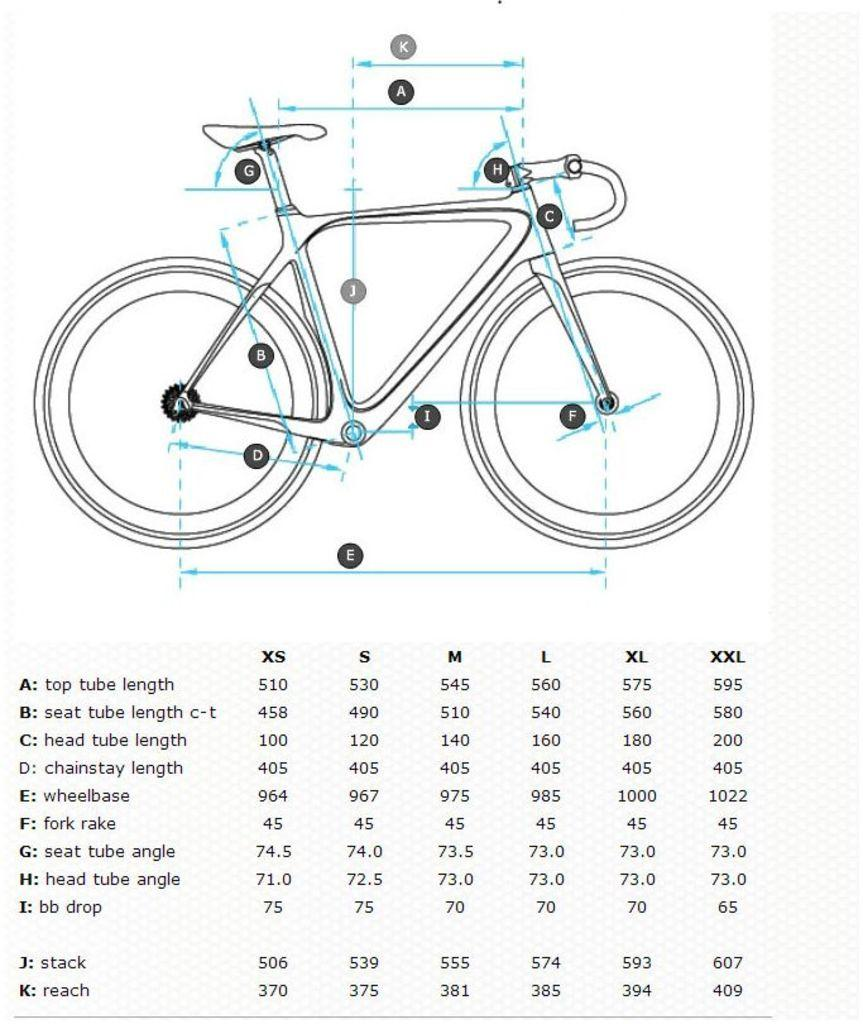Provide a one-sentence caption for the provided image. bicycle diagram with various lengths of parts such as wheelbase. 